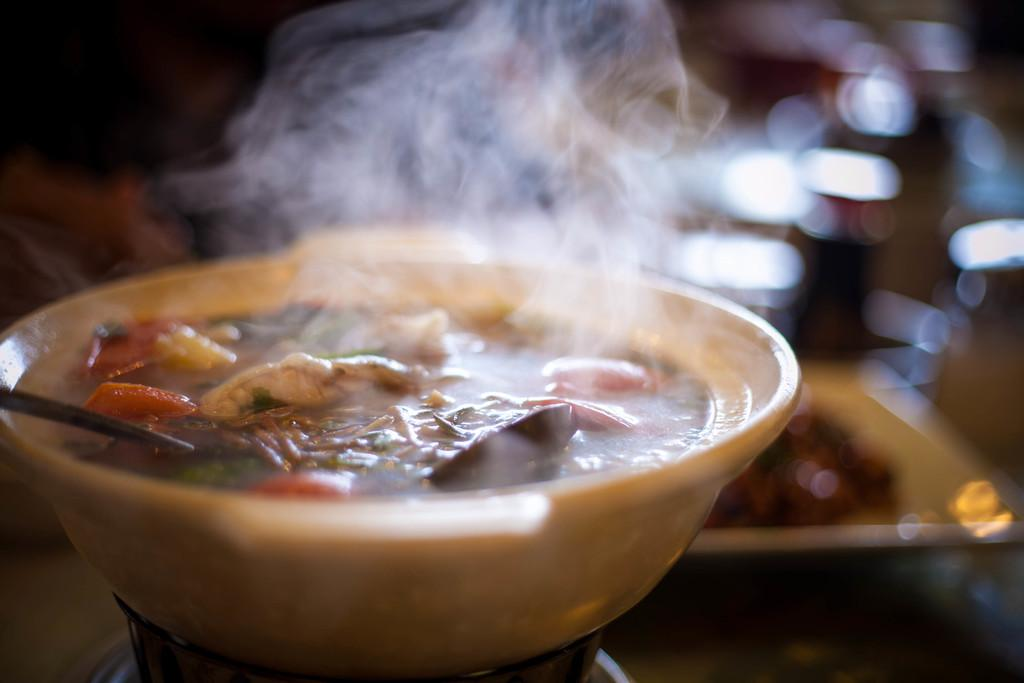What is in the bowl that is visible in the image? There is food in a bowl in the image. What utensil is present in the image? There is a spoon in the image. Can you describe the background of the image? The background of the image is blurry. What time of day is it in the image, based on the presence of a ball? There is no ball present in the image, so it is not possible to determine the time of day based on that information. 